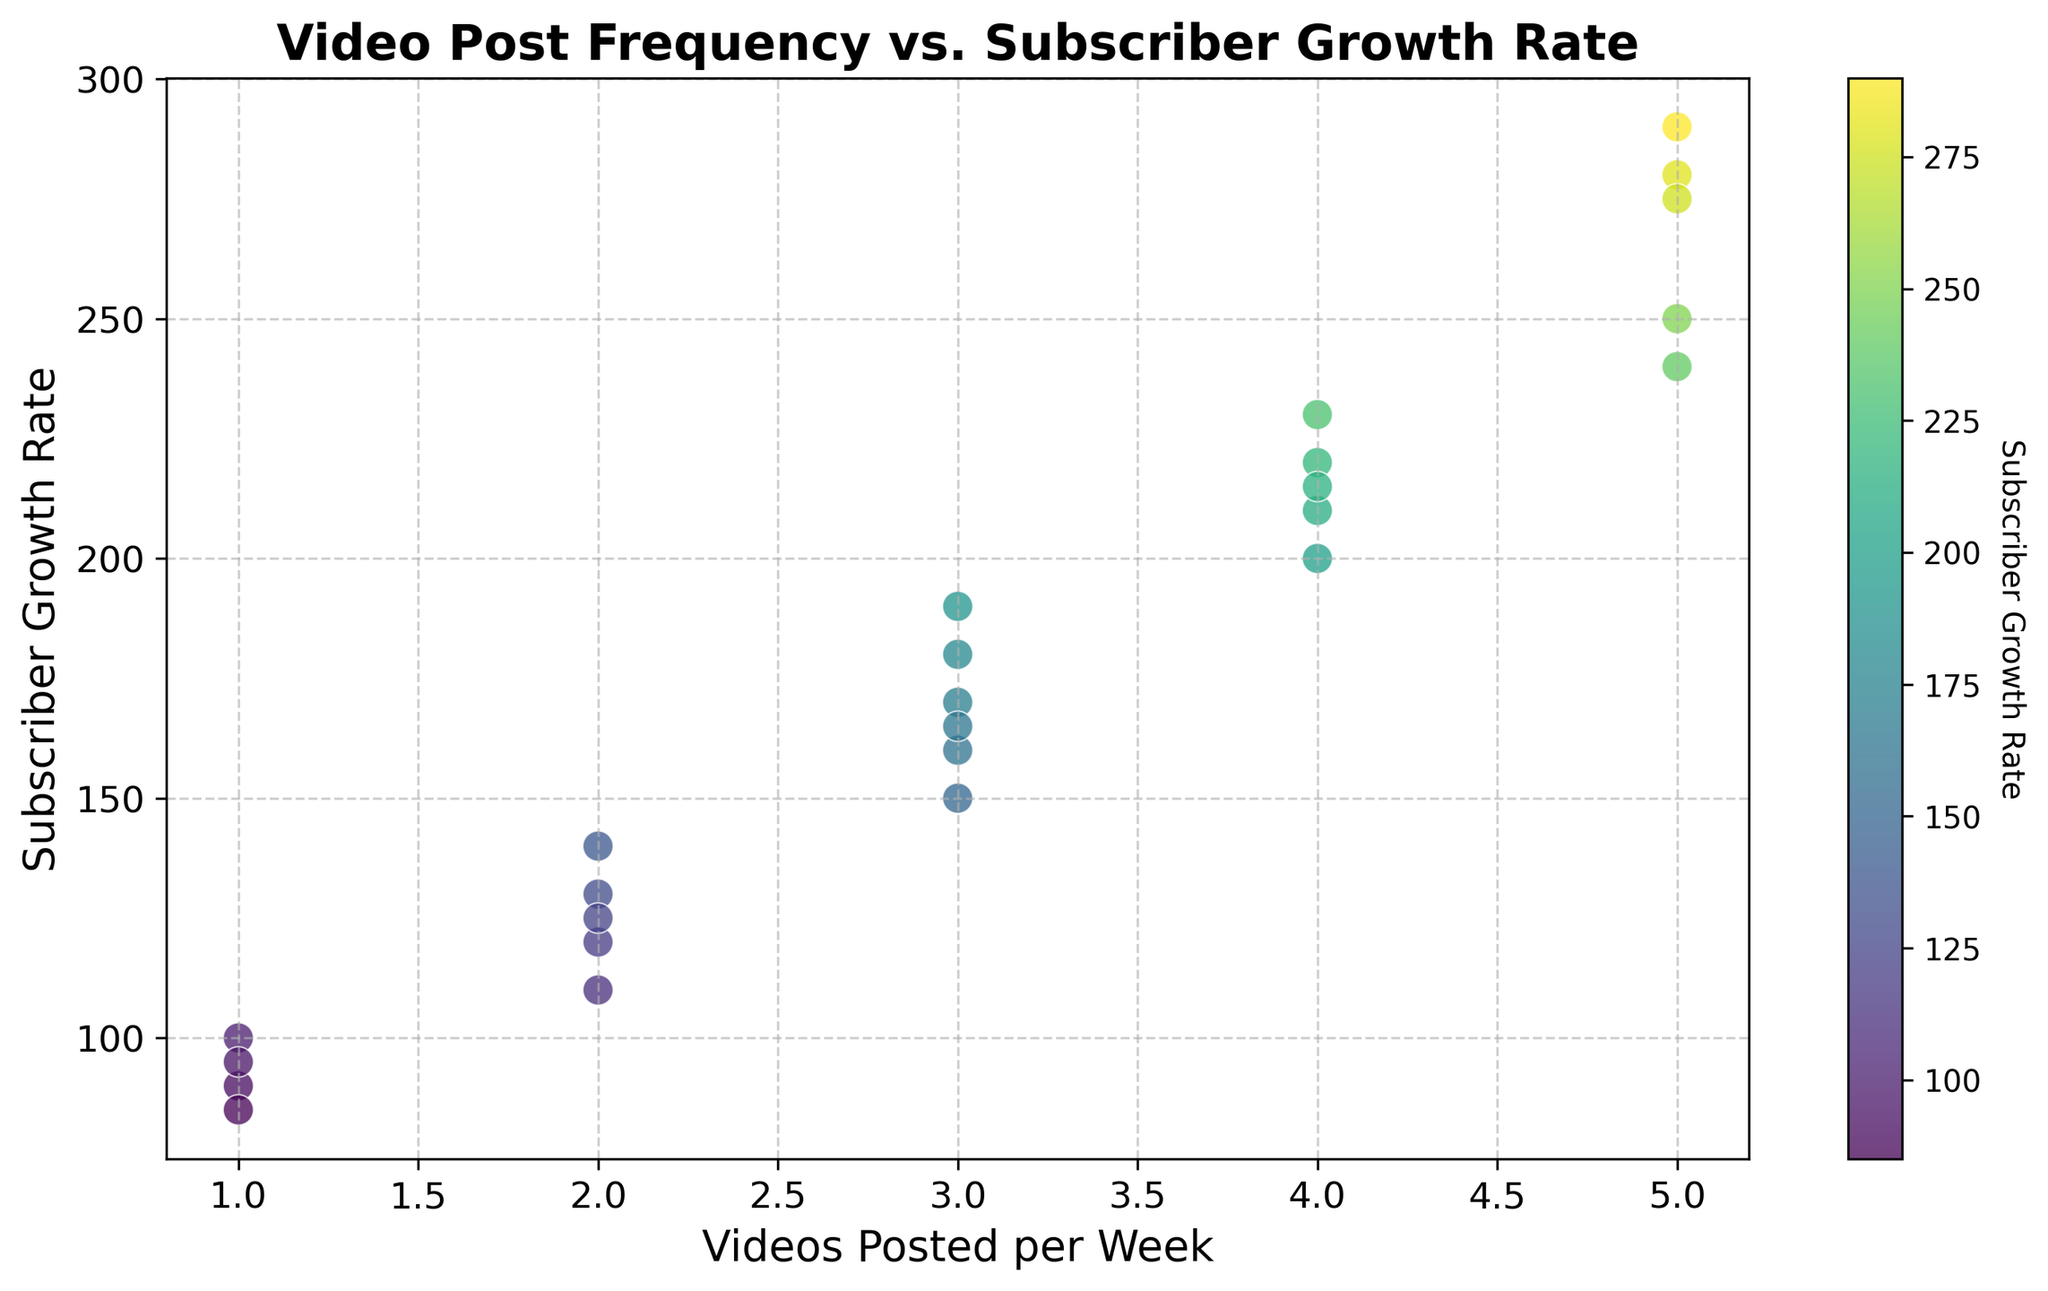How many weeks had exactly 3 videos posted? Look at the x-axis and count the number of points with the coordinate (3, y) for any value of y. There are 5 points lying on the x-axis value of 3.
Answer: 5 What is the trend between the number of videos posted and subscriber growth rate? Observe the scatter plot: as the number of videos posted per week increases from 1 to 5, there is a clear upward trend in subscriber growth rate. Higher video post frequencies generally correspond to higher subscriber growth rates.
Answer: Increasing trend Which weeks had the highest subscriber growth rate, and how many videos were posted those weeks? Identify the points with the highest y-values by looking at the y-axis. Two points have a growth rate of 290 and 280, respectively. Both of those points correspond to 5 videos posted per week.
Answer: 12th week (5 videos) and 8th week (5 videos) How does posting 1 video per week affect subscriber growth, compared to posting 5 videos per week? Compare the growth rate values of points when x=1 to those when x=5. Points at x=1 have growth rates 90, 100, 85, and 95, while points at x=5 have growth rates 240, 280, 290, 250, and 275. Generally, posting 5 videos per week results in much higher growth rates.
Answer: Posting 5 videos results in higher growth rates What's the average subscriber growth rate for weeks when 2 videos were posted? Identify the points where x=2: 120, 110, 130, 140, 125. Compute the average: (120+110+130+140+125) / 5 = 625 / 5 = 125.
Answer: 125 Is there an outlier where fewer videos resulted in higher subscriber growth? Visually scan for any x-values of 1 or 2 with significantly higher y-values (growth rates). There is no evident outlier where fewer videos posted resulted in higher subscriber growth; highest at x=2 is around 140, which is moderate.
Answer: No Which video post frequency has the most consistent subscriber growth rate? Compare the spread (range) of y-values for each x (video frequency). x=4 shows moderate consistency with growth rates ranging from 200 to 230.
Answer: 4 videos per week Does posting exactly 4 videos yield higher growth compared to posting exactly 3 videos on average? Calculate the average growth rates for both frequencies. 4 videos: (200+220+210+230+215) / 5 = 1075 / 5 = 215. 3 videos: (150+160+170+180+165) / 5 = 825 / 5 = 165. Compare them.
Answer: Yes, 4 videos have a higher average growth How many unique subscriber growth rates are observed in the plot? Count the number of distinct y-values in the scatter plot by reading the respective y-coordinate values from each point. Unique values: 150, 200, 240, 120, 160, 90, 220, 280, 170, 110, 210, 290, 130, 180, 100, 230, 250, 140, 190, 85, 215, 275, 125, 180.
Answer: 24 